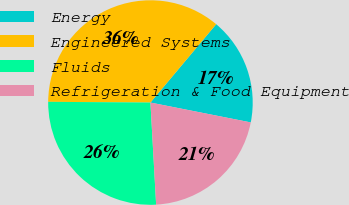Convert chart. <chart><loc_0><loc_0><loc_500><loc_500><pie_chart><fcel>Energy<fcel>Engineered Systems<fcel>Fluids<fcel>Refrigeration & Food Equipment<nl><fcel>17.0%<fcel>36.0%<fcel>26.0%<fcel>21.0%<nl></chart> 